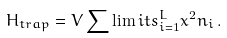Convert formula to latex. <formula><loc_0><loc_0><loc_500><loc_500>H _ { t r a p } = V \sum \lim i t s ^ { L } _ { i = 1 } x ^ { 2 } n _ { i } \, .</formula> 